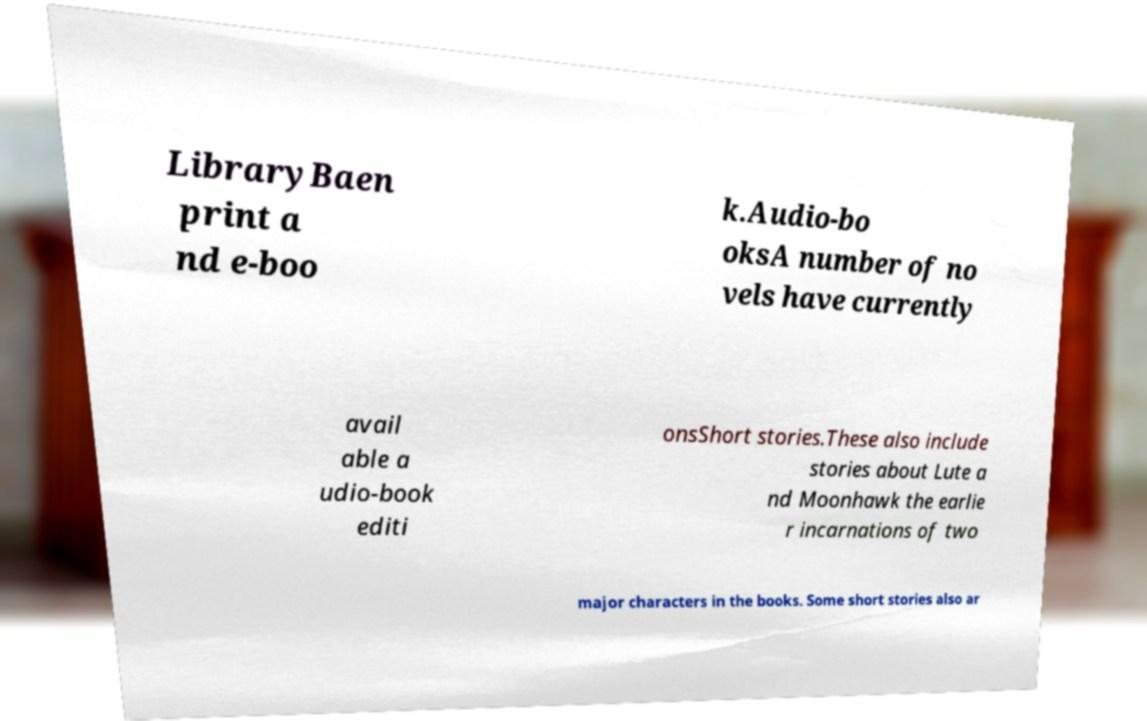Could you assist in decoding the text presented in this image and type it out clearly? LibraryBaen print a nd e-boo k.Audio-bo oksA number of no vels have currently avail able a udio-book editi onsShort stories.These also include stories about Lute a nd Moonhawk the earlie r incarnations of two major characters in the books. Some short stories also ar 